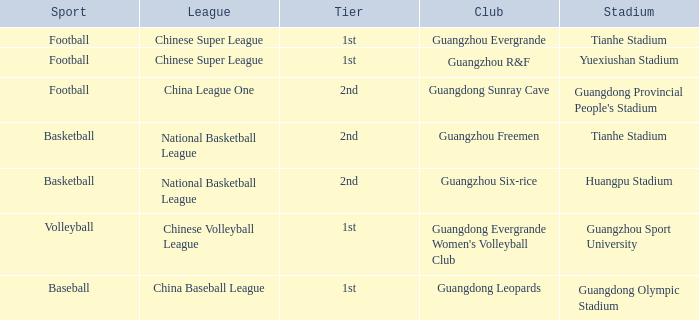Which stadium is for football with the China League One? Guangdong Provincial People's Stadium. 